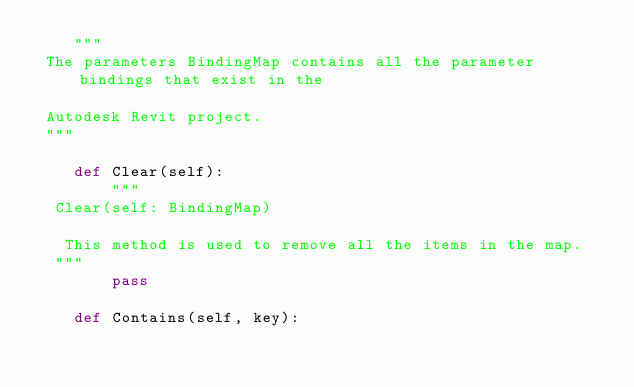<code> <loc_0><loc_0><loc_500><loc_500><_Python_>    """
 The parameters BindingMap contains all the parameter bindings that exist in the

 Autodesk Revit project.
 """

    def Clear(self):
        """
  Clear(self: BindingMap)

   This method is used to remove all the items in the map.
  """
        pass

    def Contains(self, key):</code> 